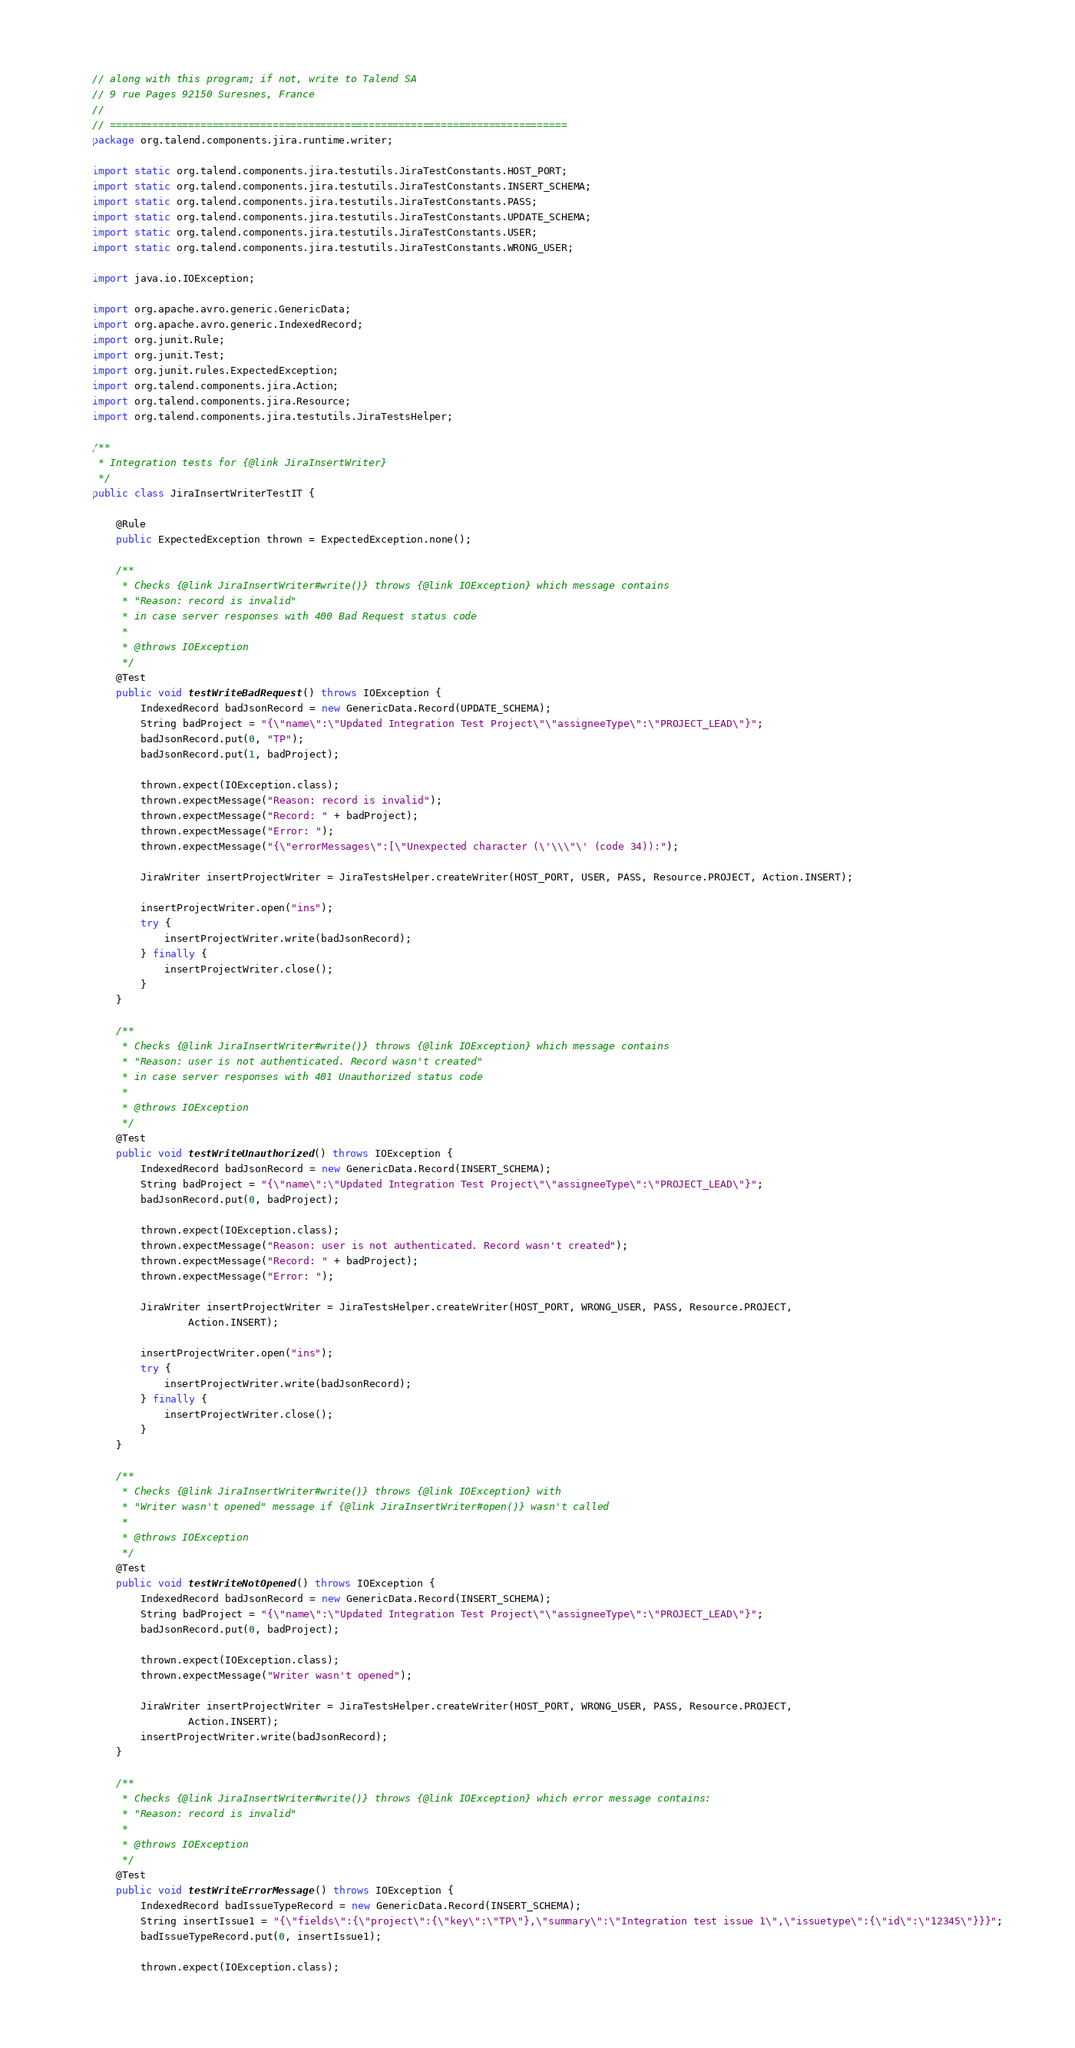<code> <loc_0><loc_0><loc_500><loc_500><_Java_>// along with this program; if not, write to Talend SA
// 9 rue Pages 92150 Suresnes, France
//
// ============================================================================
package org.talend.components.jira.runtime.writer;

import static org.talend.components.jira.testutils.JiraTestConstants.HOST_PORT;
import static org.talend.components.jira.testutils.JiraTestConstants.INSERT_SCHEMA;
import static org.talend.components.jira.testutils.JiraTestConstants.PASS;
import static org.talend.components.jira.testutils.JiraTestConstants.UPDATE_SCHEMA;
import static org.talend.components.jira.testutils.JiraTestConstants.USER;
import static org.talend.components.jira.testutils.JiraTestConstants.WRONG_USER;

import java.io.IOException;

import org.apache.avro.generic.GenericData;
import org.apache.avro.generic.IndexedRecord;
import org.junit.Rule;
import org.junit.Test;
import org.junit.rules.ExpectedException;
import org.talend.components.jira.Action;
import org.talend.components.jira.Resource;
import org.talend.components.jira.testutils.JiraTestsHelper;

/**
 * Integration tests for {@link JiraInsertWriter}
 */
public class JiraInsertWriterTestIT {
    
    @Rule
    public ExpectedException thrown = ExpectedException.none();

    /**
     * Checks {@link JiraInsertWriter#write()} throws {@link IOException} which message contains
     * "Reason: record is invalid" 
     * in case server responses with 400 Bad Request status code
     * 
     * @throws IOException
     */
    @Test
    public void testWriteBadRequest() throws IOException {
        IndexedRecord badJsonRecord = new GenericData.Record(UPDATE_SCHEMA);
        String badProject = "{\"name\":\"Updated Integration Test Project\"\"assigneeType\":\"PROJECT_LEAD\"}";
        badJsonRecord.put(0, "TP");
        badJsonRecord.put(1, badProject);
        
        thrown.expect(IOException.class);
        thrown.expectMessage("Reason: record is invalid");
        thrown.expectMessage("Record: " + badProject);
        thrown.expectMessage("Error: ");
        thrown.expectMessage("{\"errorMessages\":[\"Unexpected character (\'\\\"\' (code 34)):");

        JiraWriter insertProjectWriter = JiraTestsHelper.createWriter(HOST_PORT, USER, PASS, Resource.PROJECT, Action.INSERT);

        insertProjectWriter.open("ins");
        try {
            insertProjectWriter.write(badJsonRecord);
        } finally {
            insertProjectWriter.close();
        }
    }

    /**
     * Checks {@link JiraInsertWriter#write()} throws {@link IOException} which message contains
     * "Reason: user is not authenticated. Record wasn't created" 
     * in case server responses with 401 Unauthorized status code
     * 
     * @throws IOException
     */
    @Test
    public void testWriteUnauthorized() throws IOException {
        IndexedRecord badJsonRecord = new GenericData.Record(INSERT_SCHEMA);
        String badProject = "{\"name\":\"Updated Integration Test Project\"\"assigneeType\":\"PROJECT_LEAD\"}";
        badJsonRecord.put(0, badProject);
        
        thrown.expect(IOException.class);
        thrown.expectMessage("Reason: user is not authenticated. Record wasn't created");
        thrown.expectMessage("Record: " + badProject);
        thrown.expectMessage("Error: ");
        
        JiraWriter insertProjectWriter = JiraTestsHelper.createWriter(HOST_PORT, WRONG_USER, PASS, Resource.PROJECT,
                Action.INSERT);

        insertProjectWriter.open("ins");
        try {
            insertProjectWriter.write(badJsonRecord);
        } finally {
            insertProjectWriter.close();
        }
    }

    /**
     * Checks {@link JiraInsertWriter#write()} throws {@link IOException} with 
     * "Writer wasn't opened" message if {@link JiraInsertWriter#open()} wasn't called
     * 
     * @throws IOException
     */
    @Test
    public void testWriteNotOpened() throws IOException {
        IndexedRecord badJsonRecord = new GenericData.Record(INSERT_SCHEMA);
        String badProject = "{\"name\":\"Updated Integration Test Project\"\"assigneeType\":\"PROJECT_LEAD\"}";
        badJsonRecord.put(0, badProject);
        
        thrown.expect(IOException.class);
        thrown.expectMessage("Writer wasn't opened");

        JiraWriter insertProjectWriter = JiraTestsHelper.createWriter(HOST_PORT, WRONG_USER, PASS, Resource.PROJECT,
                Action.INSERT);
        insertProjectWriter.write(badJsonRecord);
    }

    /**
     * Checks {@link JiraInsertWriter#write()} throws {@link IOException} which error message contains:
     * "Reason: record is invalid"
     * 
     * @throws IOException
     */
    @Test
    public void testWriteErrorMessage() throws IOException {
        IndexedRecord badIssueTypeRecord = new GenericData.Record(INSERT_SCHEMA);
        String insertIssue1 = "{\"fields\":{\"project\":{\"key\":\"TP\"},\"summary\":\"Integration test issue 1\",\"issuetype\":{\"id\":\"12345\"}}}";
        badIssueTypeRecord.put(0, insertIssue1);
        
        thrown.expect(IOException.class);</code> 